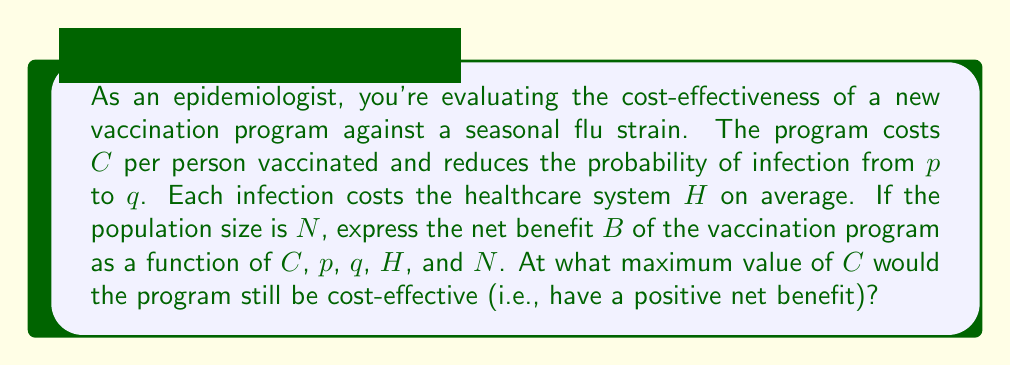Solve this math problem. Let's approach this step-by-step:

1) First, let's calculate the expected cost of infections without the vaccination program:
   $$\text{Cost without program} = N \cdot p \cdot H$$

2) Now, let's calculate the expected cost with the vaccination program:
   $$\text{Cost with program} = N \cdot C + N \cdot q \cdot H$$

3) The net benefit $B$ is the difference between these two:
   $$B = (N \cdot p \cdot H) - (N \cdot C + N \cdot q \cdot H)$$

4) Simplify the equation:
   $$B = N \cdot p \cdot H - N \cdot C - N \cdot q \cdot H$$
   $$B = N \cdot (p \cdot H - C - q \cdot H)$$
   $$B = N \cdot (H \cdot (p - q) - C)$$

5) For the program to be cost-effective, $B$ must be positive:
   $$N \cdot (H \cdot (p - q) - C) > 0$$

6) Solve for $C$:
   $$H \cdot (p - q) - C > 0$$
   $$H \cdot (p - q) > C$$

7) Therefore, the maximum value of $C$ for the program to be cost-effective is:
   $$C_{\text{max}} = H \cdot (p - q)$$
Answer: $C_{\text{max}} = H \cdot (p - q)$ 